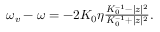<formula> <loc_0><loc_0><loc_500><loc_500>\begin{array} { r } { \omega _ { v } - \omega = - 2 K _ { 0 } \eta \frac { K _ { 0 } ^ { - 1 } - | z | ^ { 2 } } { K _ { 0 } ^ { - 1 } + | z | ^ { 2 } } . } \end{array}</formula> 